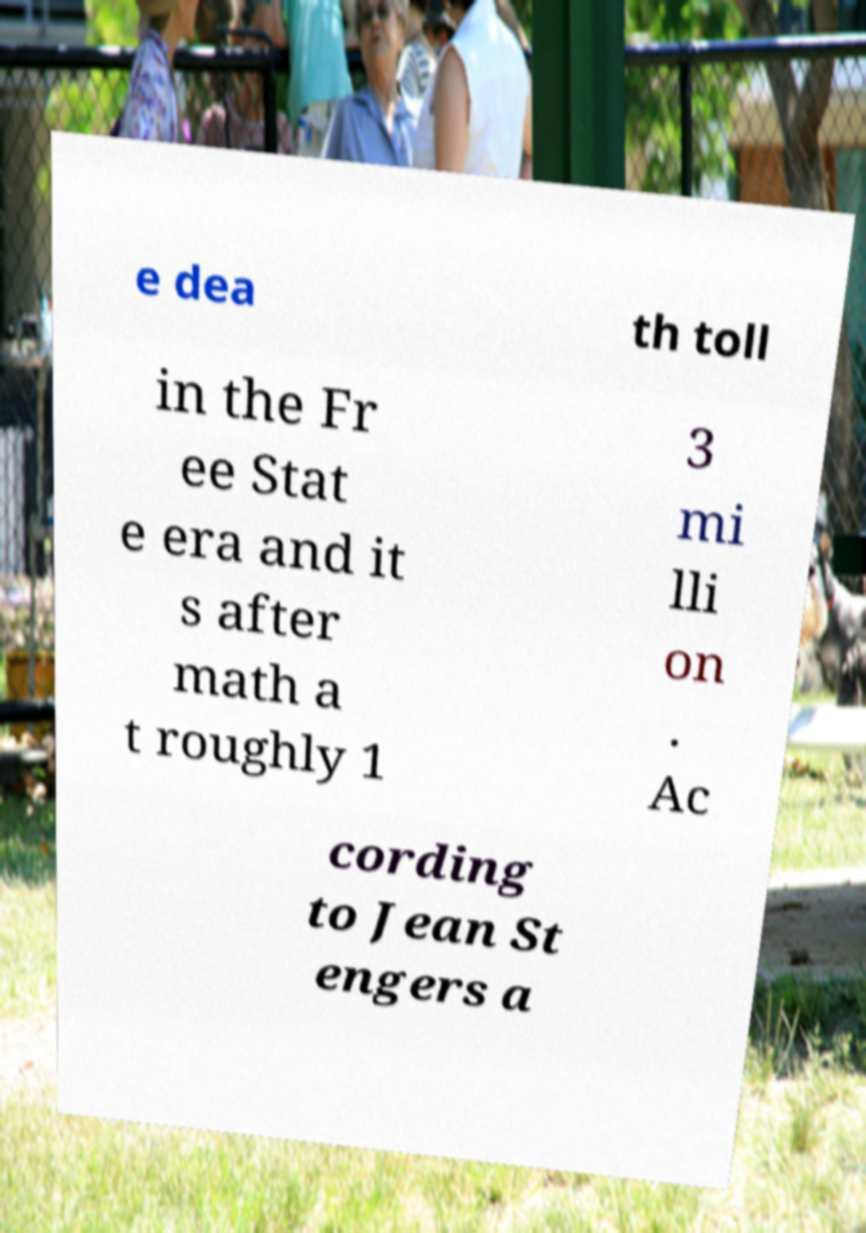Can you accurately transcribe the text from the provided image for me? e dea th toll in the Fr ee Stat e era and it s after math a t roughly 1 3 mi lli on . Ac cording to Jean St engers a 